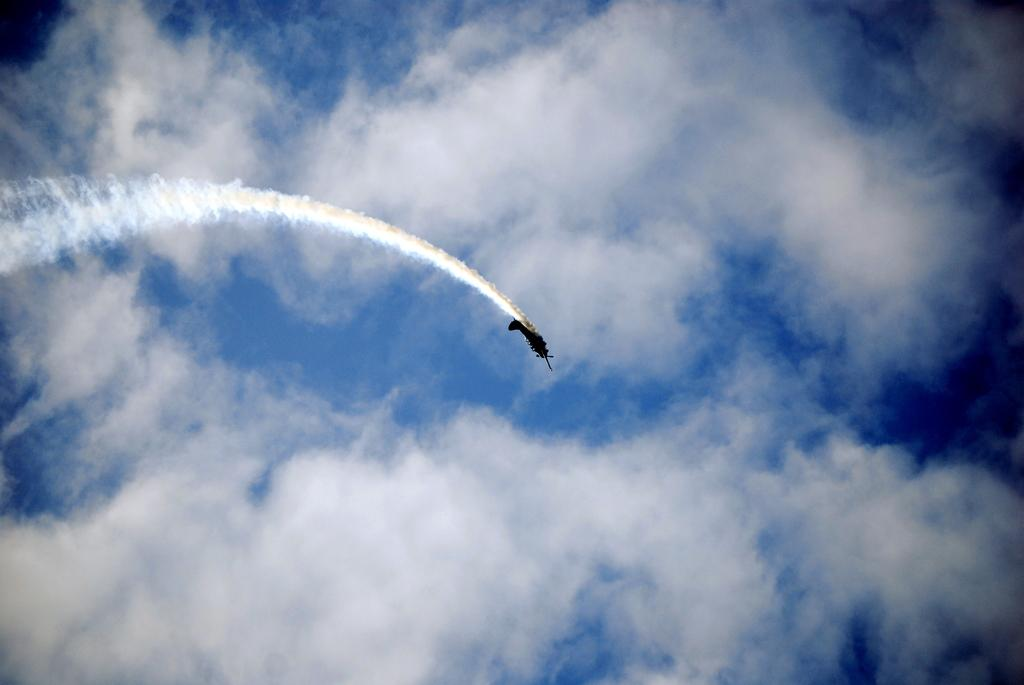What is the main subject of the image? The main subject of the image is a plane. Can you describe the plane's location in the image? The plane is in the air. What else can be seen in the image besides the plane? There are clouds visible in the image. What type of event is happening on the ground in the image? There is no event happening on the ground in the image; the focus is on the plane in the air. 